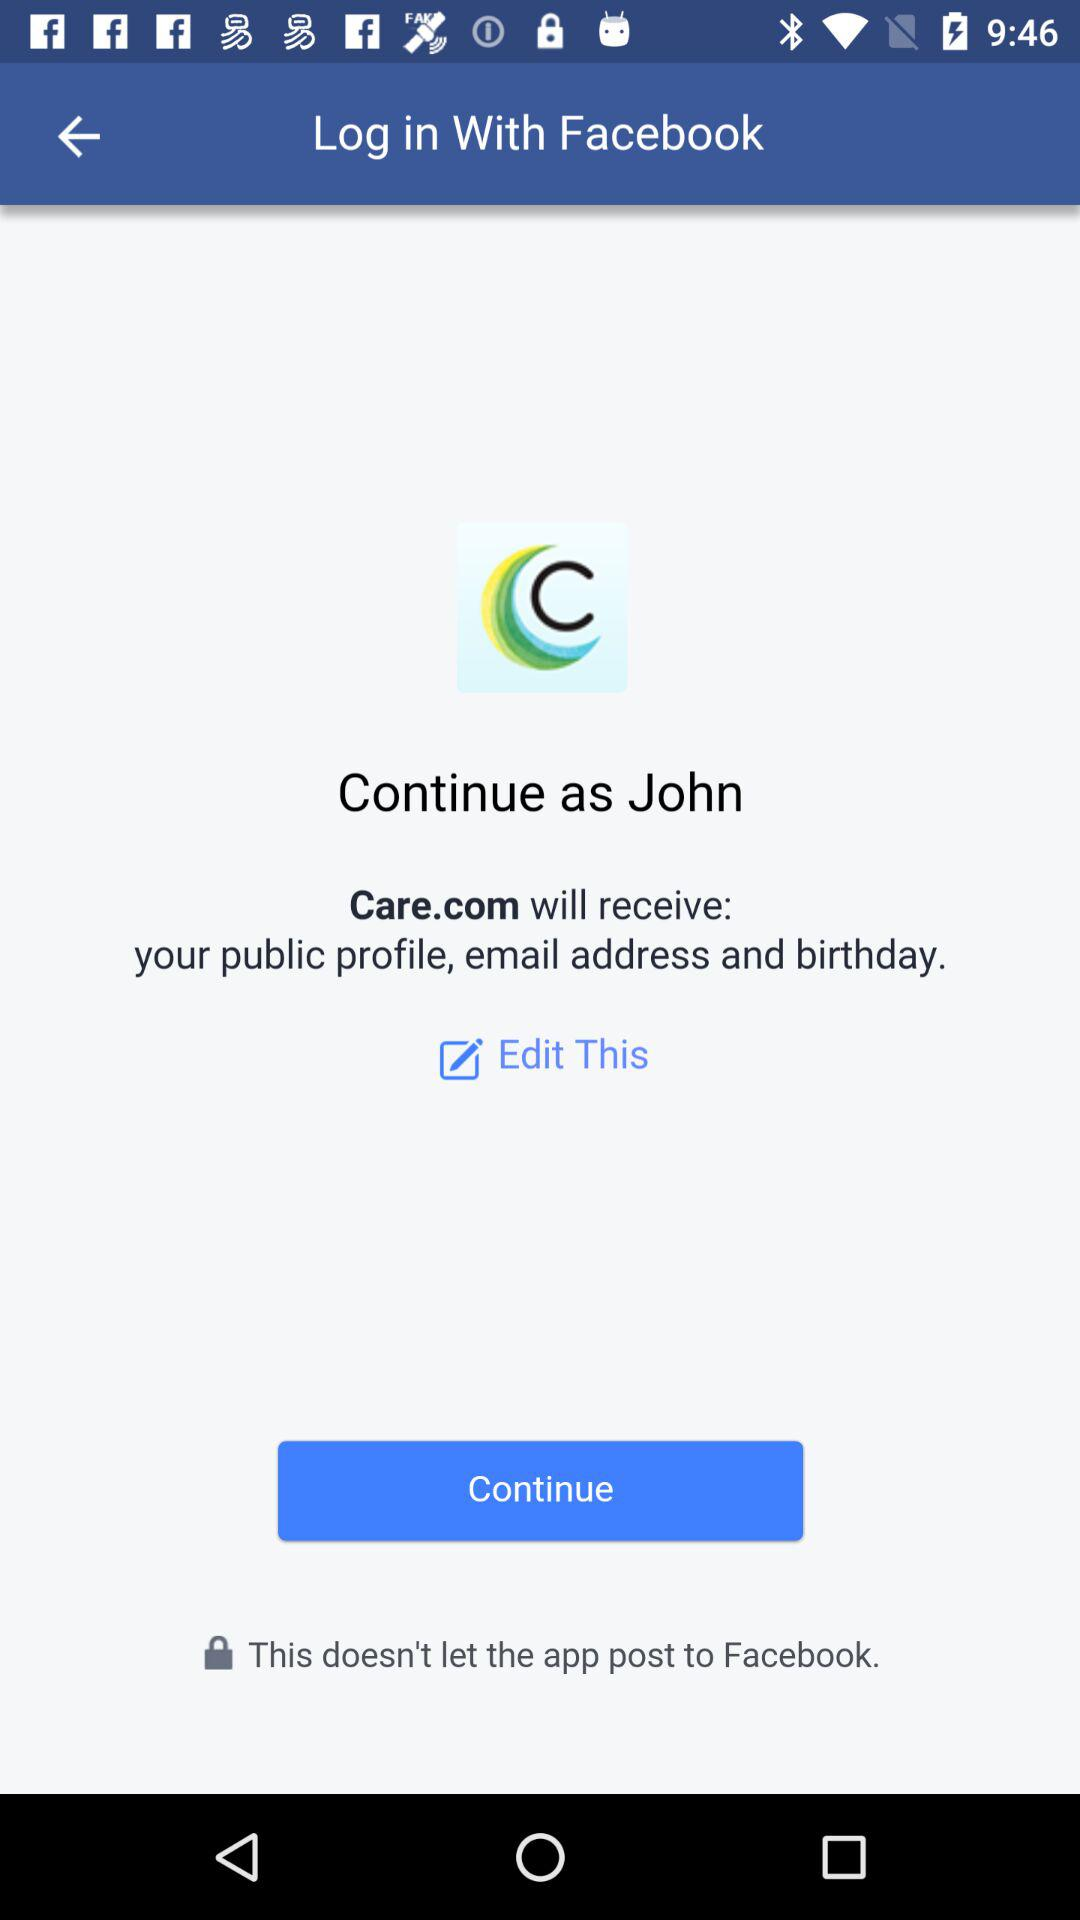What application is asking for permission? The application is "Care.com". 